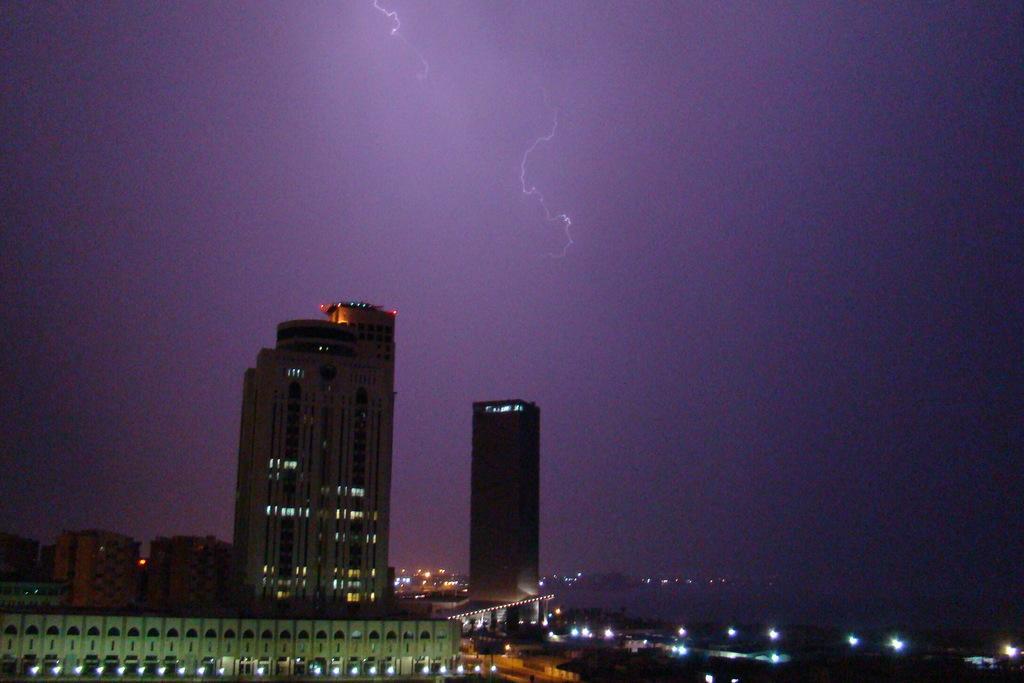How would you summarize this image in a sentence or two? In this picture we can see buildings and in the background we can see sky. 